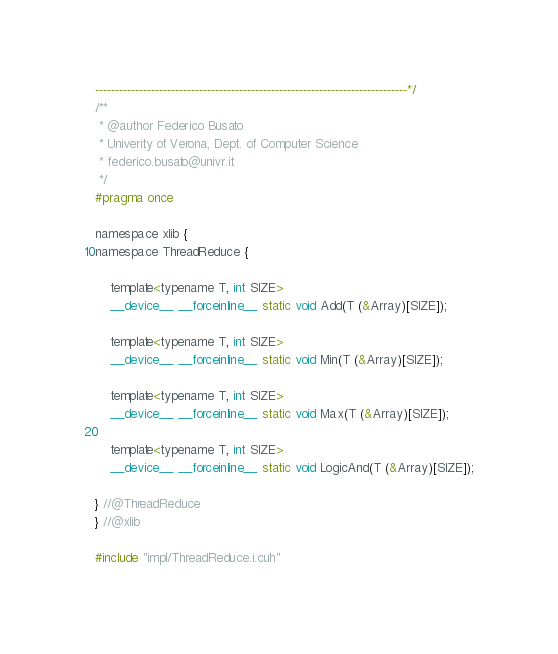<code> <loc_0><loc_0><loc_500><loc_500><_Cuda_>------------------------------------------------------------------------------*/
/**
 * @author Federico Busato
 * Univerity of Verona, Dept. of Computer Science
 * federico.busato@univr.it
 */
#pragma once

namespace xlib {
namespace ThreadReduce {

    template<typename T, int SIZE>
    __device__ __forceinline__ static void Add(T (&Array)[SIZE]);

    template<typename T, int SIZE>
    __device__ __forceinline__ static void Min(T (&Array)[SIZE]);

    template<typename T, int SIZE>
    __device__ __forceinline__ static void Max(T (&Array)[SIZE]);

    template<typename T, int SIZE>
    __device__ __forceinline__ static void LogicAnd(T (&Array)[SIZE]);

} //@ThreadReduce
} //@xlib

#include "impl/ThreadReduce.i.cuh"
</code> 